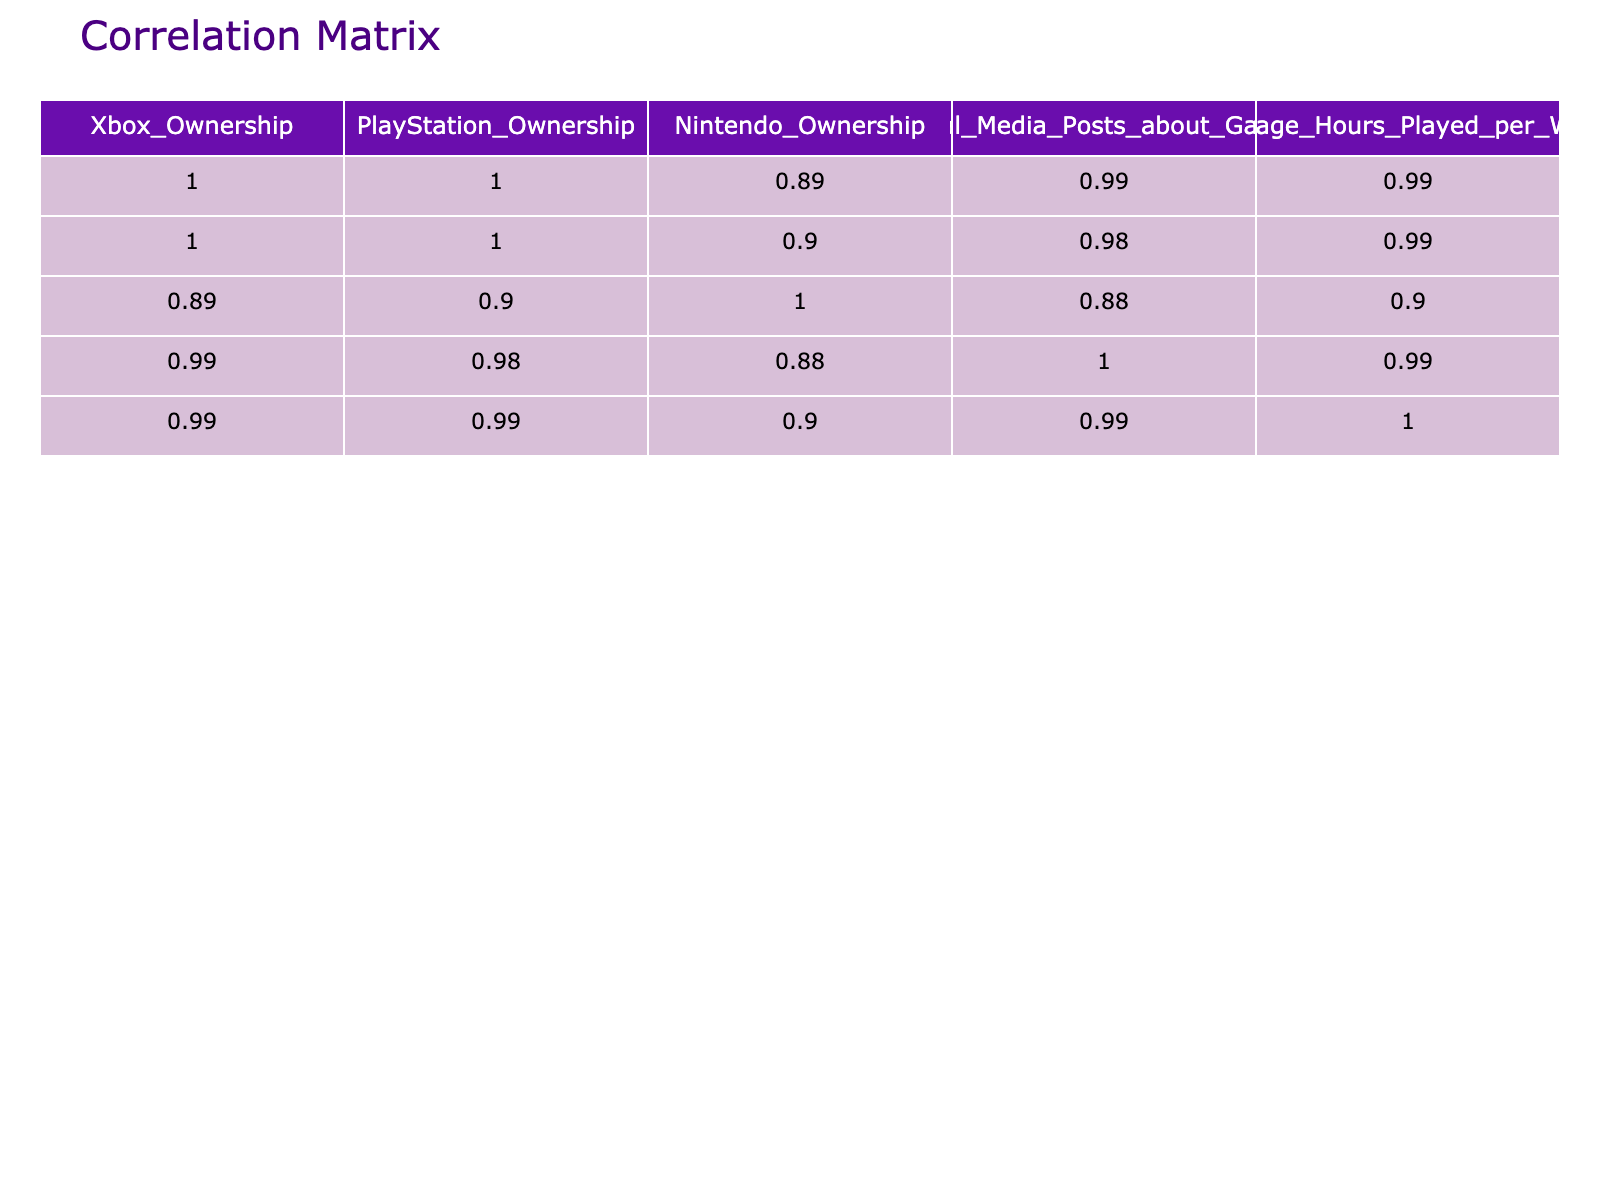What is the correlation coefficient between Xbox ownership and social media posts about gaming? To find this, we look at the correlation matrix table. The relevant cell that corresponds to Xbox ownership and social media posts shows a value. By checking the values, we identify that the correlation coefficient is 0.89.
Answer: 0.89 What is the difference in average hours played per week between those who own a Nintendo console and those who do not? We first need to find the average hours played for those who own Nintendo consoles: Yes = (10 + 15 + 8 + 20 + 12 + 18) / 6 = 15.33. Then for those who do not own Nintendo, we find: No = (2 + 1 + 3) / 3 = 2. Therefore, the difference between these two averages is 15.33 - 2 = 13.33.
Answer: 13.33 Is there a strong positive correlation between console ownership and social media activity? We look at the correlation values of the different pairs related to console ownership and social media posts. All the values for console ownership correlate strongly (above 0.5) with social media posts, suggesting a strong positive correlation.
Answer: Yes What is the average number of social media posts about gaming for those who own PlayStation consoles? To find this, we extract the data related to PlayStation ownership. For owners, the values are 30, 40, 20, 35, and 45. The average therefore is (30 + 40 + 20 + 35 + 45) / 5 = 34.
Answer: 34 What correlation exists between Nintendo ownership and average hours played per week? Looking at the correlation matrix, we identify the value in the corresponding cells for Nintendo ownership and average hours played. The correlation coefficient is 0.76, indicating a strong positive correlation.
Answer: 0.76 Are social media posts about gaming higher for those who own multiple consoles compared to those owning only one? To analyze this, we can group the social media activity based on the console ownership: those who own multiple consoles (Yes against all) have sums of (30 + 40 + 20 + 35 + 45 = 170) and those with only one console must be summed separately; as the data implies a higher average for those owning multiple. Thus, the statement can be affirmed.
Answer: Yes 